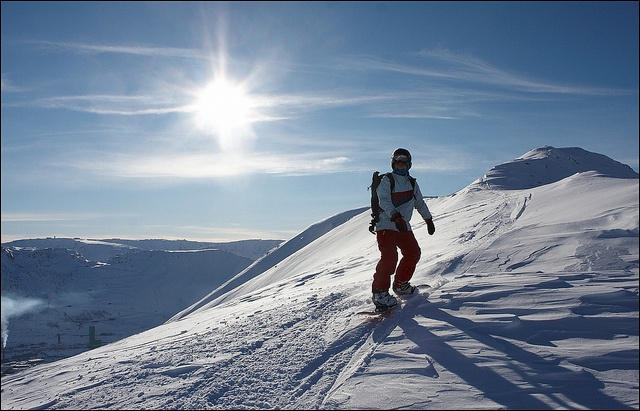Describe the objects in this image and their specific colors. I can see people in black, blue, and gray tones, backpack in black, gray, darkgray, and lightblue tones, snowboard in black, gray, darkblue, and darkgray tones, and snowboard in black, gray, and darkgray tones in this image. 